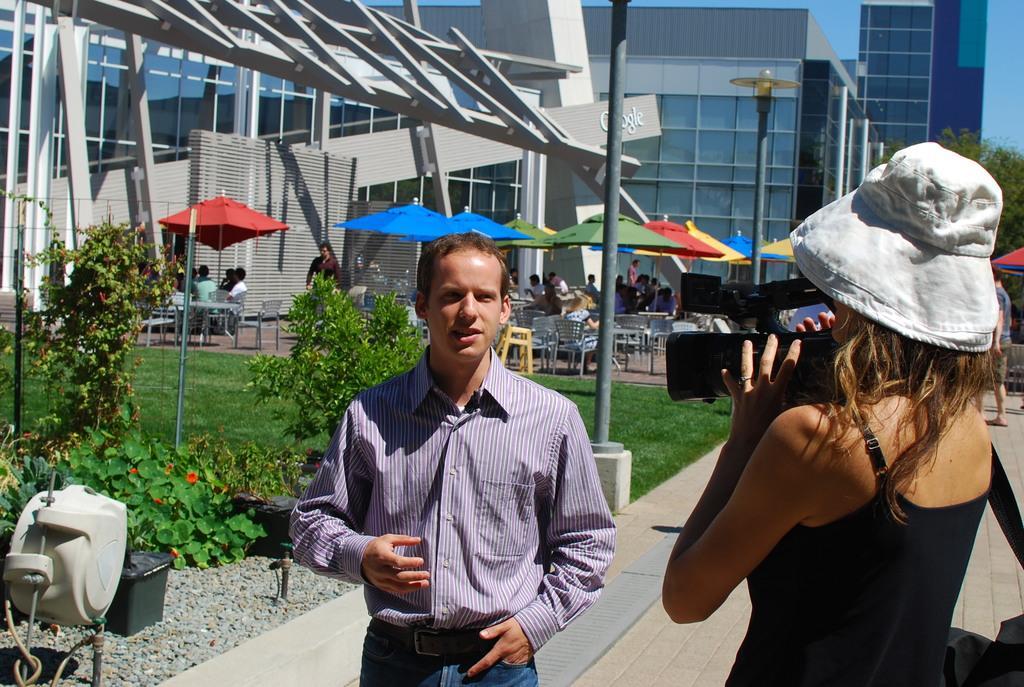Please provide a concise description of this image. In the picture I can see a woman wearing black color dress holding camera in her hands, there is a person wearing checked shirt standing, there are some plants and in the background of the picture there are some persons sitting on chairs around table beneath umbrellas, there are some buildings, trees. 